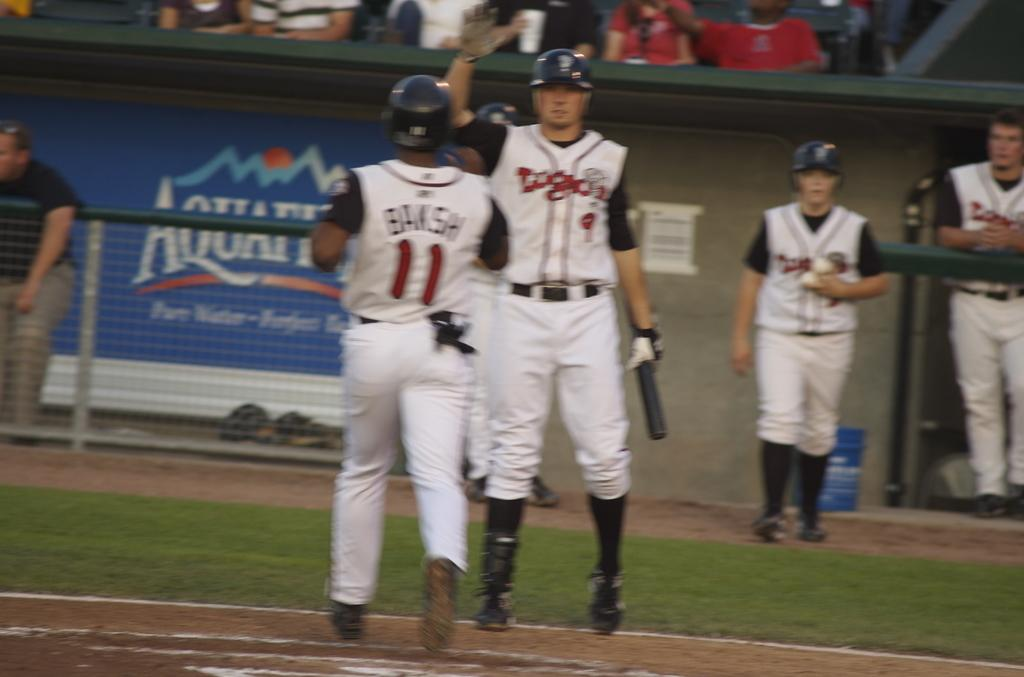<image>
Summarize the visual content of the image. Two baseball players wearing jerseys high five each other after Bansh runs in. 